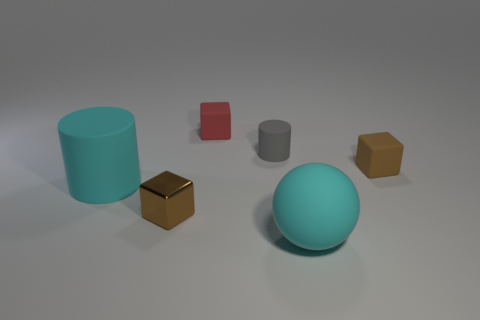Subtract all brown matte blocks. How many blocks are left? 2 Add 1 tiny yellow matte objects. How many objects exist? 7 Subtract 1 spheres. How many spheres are left? 0 Subtract all spheres. How many objects are left? 5 Subtract all green spheres. How many purple cubes are left? 0 Subtract all cyan cylinders. How many cylinders are left? 1 Subtract 1 cyan balls. How many objects are left? 5 Subtract all green balls. Subtract all yellow cylinders. How many balls are left? 1 Subtract all cylinders. Subtract all purple things. How many objects are left? 4 Add 4 cyan cylinders. How many cyan cylinders are left? 5 